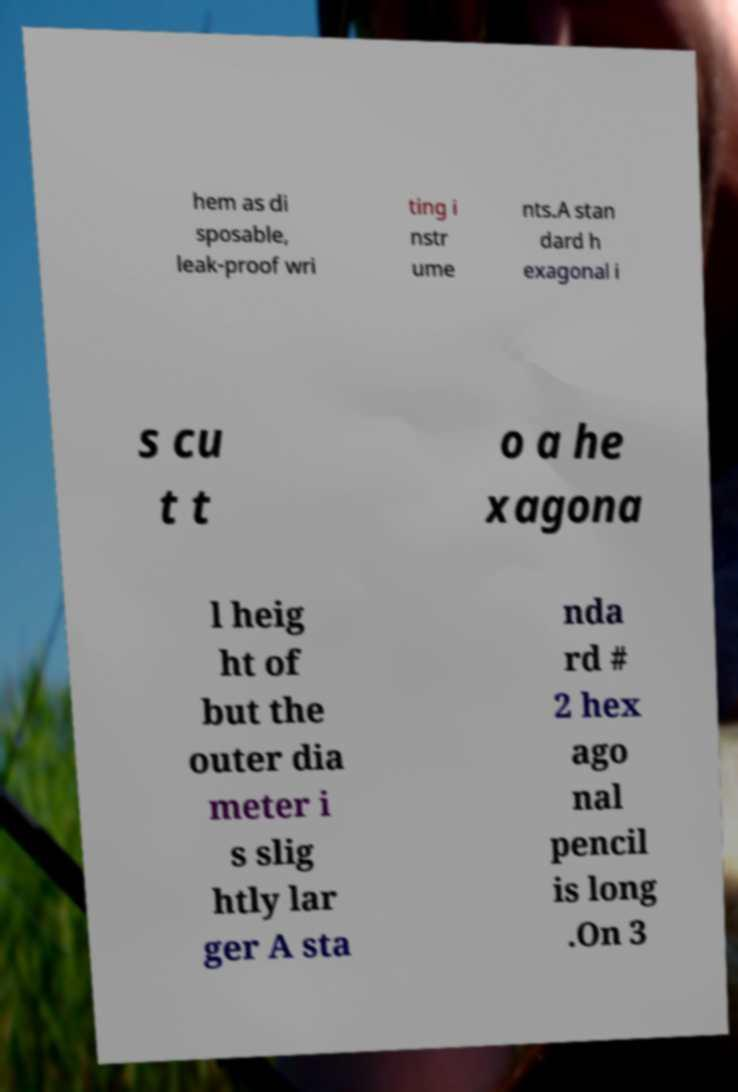What messages or text are displayed in this image? I need them in a readable, typed format. hem as di sposable, leak-proof wri ting i nstr ume nts.A stan dard h exagonal i s cu t t o a he xagona l heig ht of but the outer dia meter i s slig htly lar ger A sta nda rd # 2 hex ago nal pencil is long .On 3 